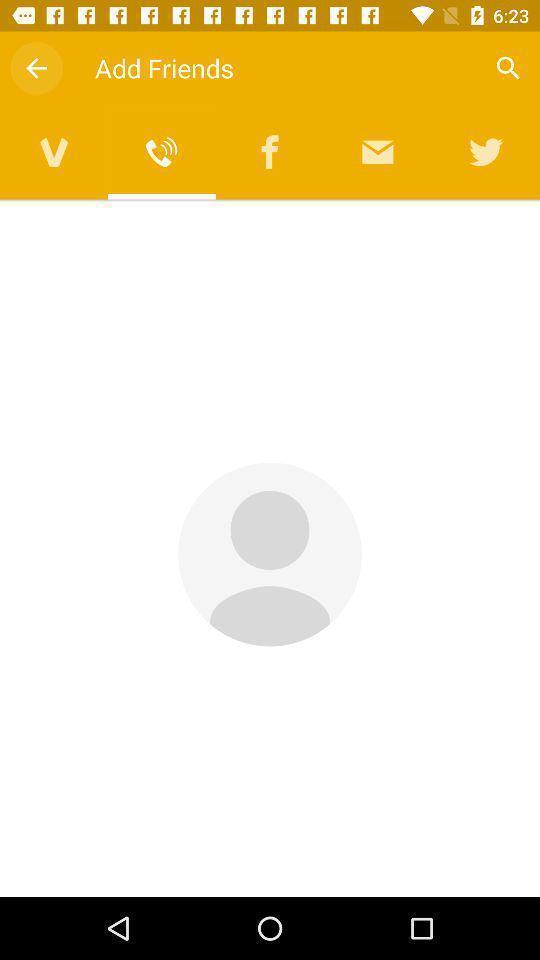Provide a detailed account of this screenshot. Screen asking to add friends. 